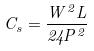Convert formula to latex. <formula><loc_0><loc_0><loc_500><loc_500>C _ { s } = \frac { W ^ { 2 } L } { 2 4 P ^ { 2 } }</formula> 